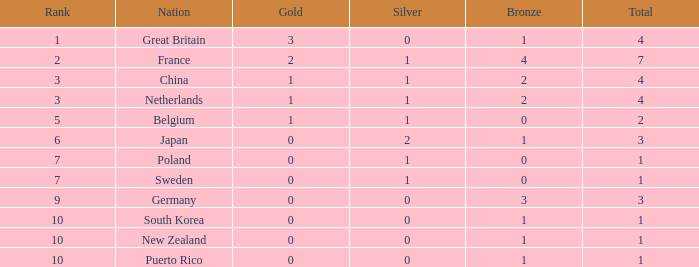What is the smallest number of gold where the total is less than 3 and the silver count is 2? None. 